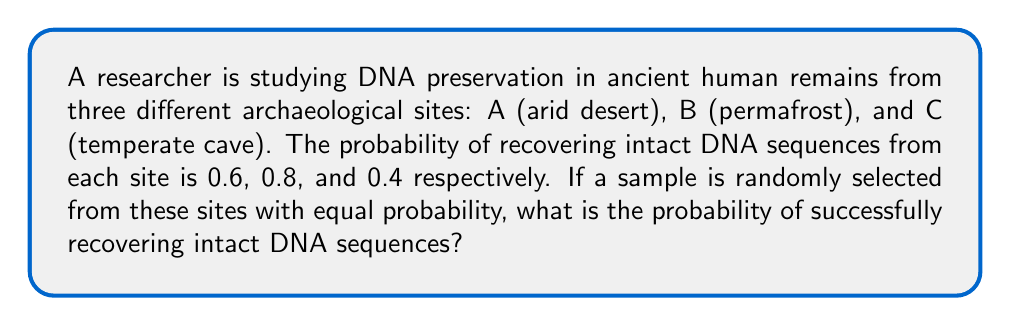Can you solve this math problem? Let's approach this step-by-step:

1) First, we need to understand what the question is asking. We're looking for the probability of success (recovering intact DNA) given that we're randomly selecting a sample from one of the three sites.

2) We're told that the sites are selected with equal probability. This means:
   $P(A) = P(B) = P(C) = \frac{1}{3}$

3) We're also given the probabilities of success for each site:
   $P(\text{Success}|A) = 0.6$
   $P(\text{Success}|B) = 0.8$
   $P(\text{Success}|C) = 0.4$

4) To find the overall probability of success, we can use the law of total probability:

   $P(\text{Success}) = P(\text{Success}|A) \cdot P(A) + P(\text{Success}|B) \cdot P(B) + P(\text{Success}|C) \cdot P(C)$

5) Substituting the values:

   $P(\text{Success}) = 0.6 \cdot \frac{1}{3} + 0.8 \cdot \frac{1}{3} + 0.4 \cdot \frac{1}{3}$

6) Simplifying:

   $P(\text{Success}) = \frac{0.6 + 0.8 + 0.4}{3} = \frac{1.8}{3} = 0.6$

Thus, the probability of successfully recovering intact DNA sequences from a randomly selected sample is 0.6 or 60%.
Answer: 0.6 